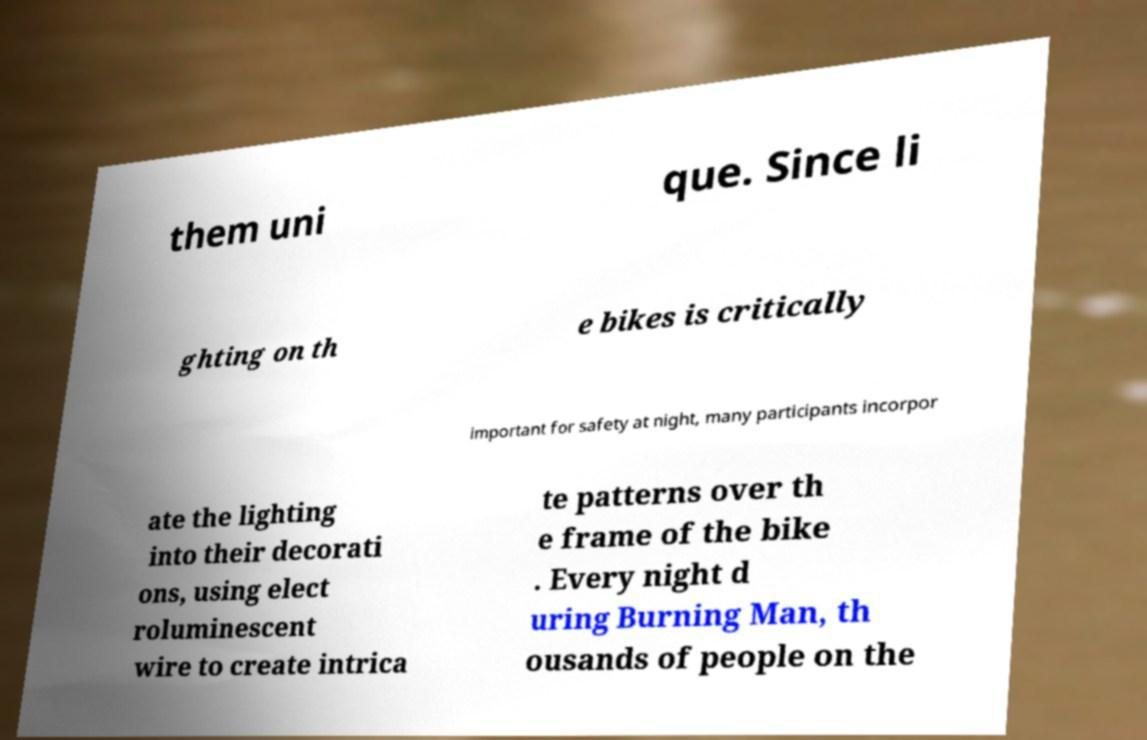I need the written content from this picture converted into text. Can you do that? them uni que. Since li ghting on th e bikes is critically important for safety at night, many participants incorpor ate the lighting into their decorati ons, using elect roluminescent wire to create intrica te patterns over th e frame of the bike . Every night d uring Burning Man, th ousands of people on the 